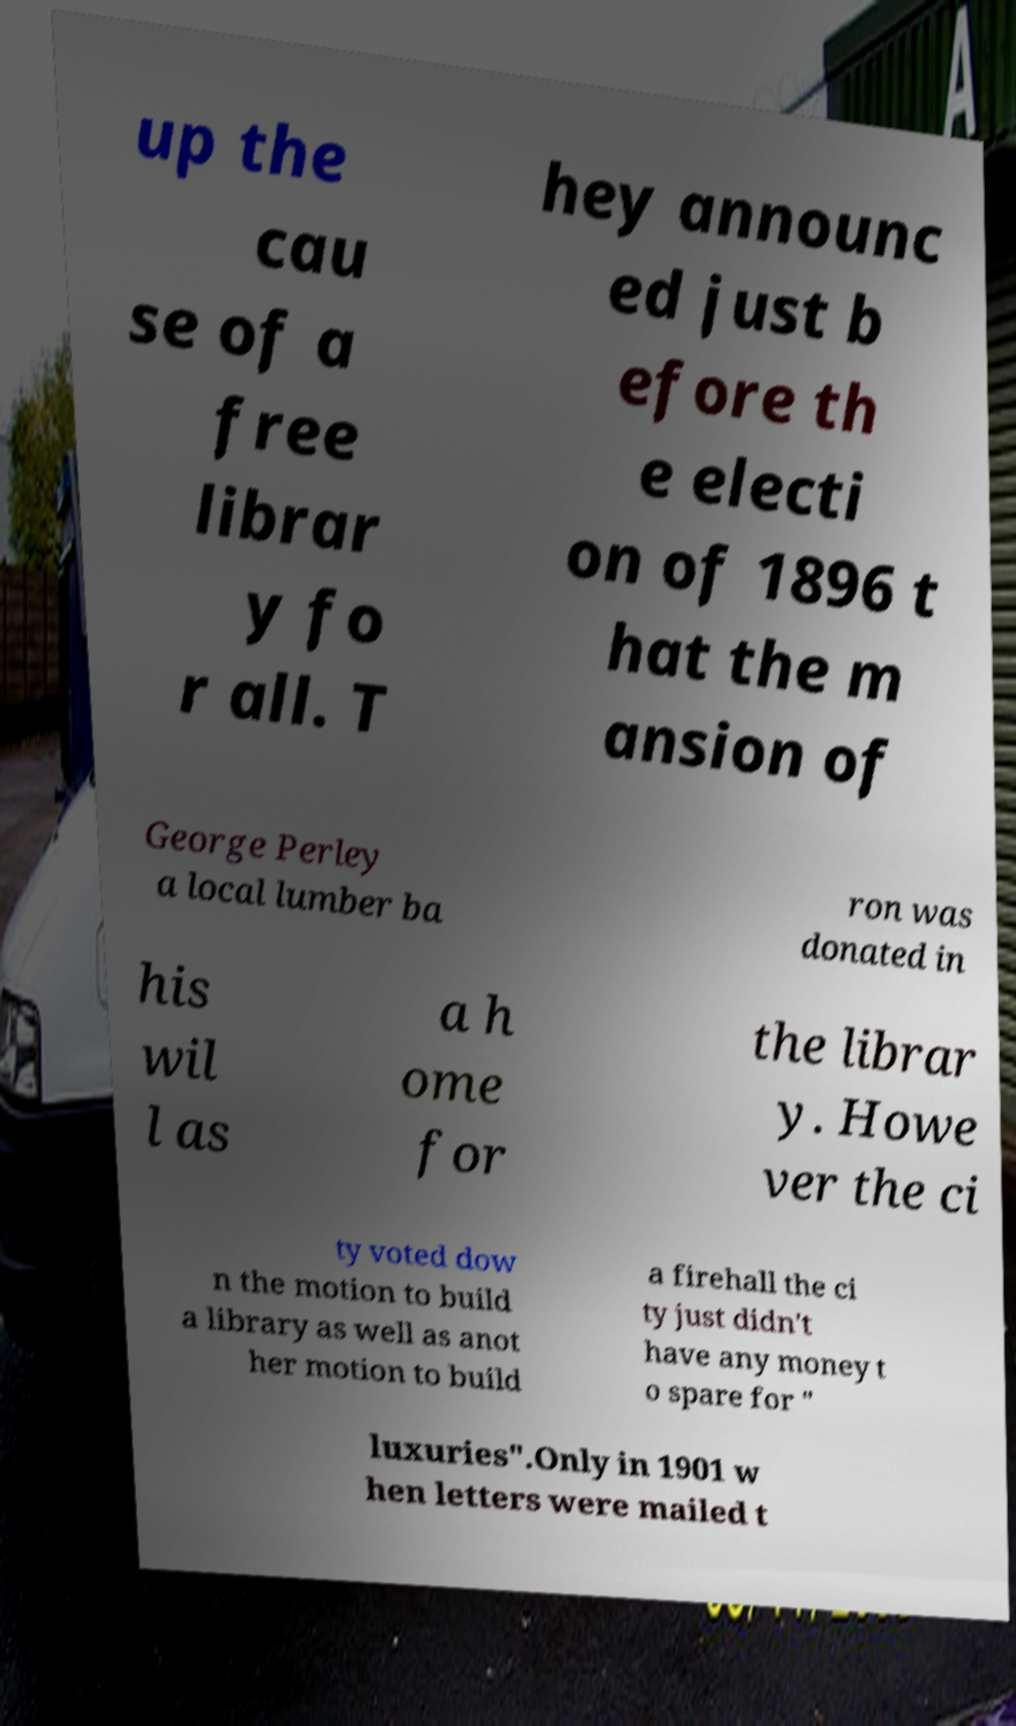Please identify and transcribe the text found in this image. up the cau se of a free librar y fo r all. T hey announc ed just b efore th e electi on of 1896 t hat the m ansion of George Perley a local lumber ba ron was donated in his wil l as a h ome for the librar y. Howe ver the ci ty voted dow n the motion to build a library as well as anot her motion to build a firehall the ci ty just didn't have any money t o spare for " luxuries".Only in 1901 w hen letters were mailed t 